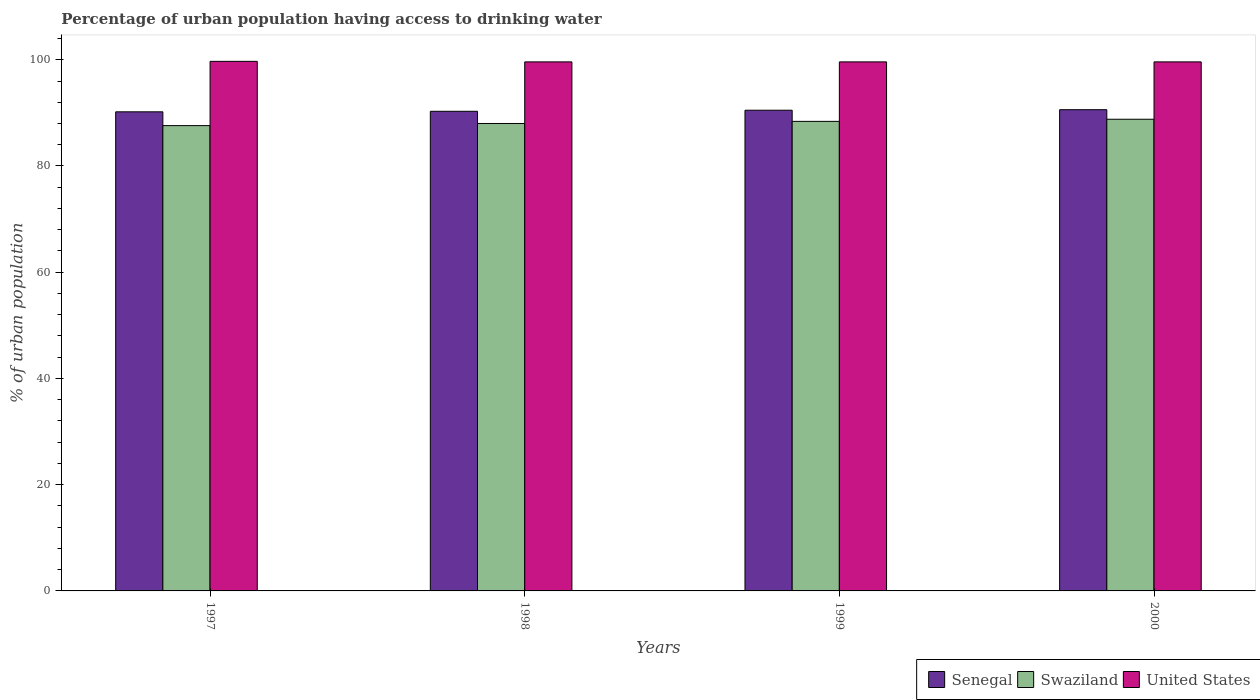How many different coloured bars are there?
Your answer should be compact. 3. Are the number of bars on each tick of the X-axis equal?
Ensure brevity in your answer.  Yes. How many bars are there on the 3rd tick from the right?
Give a very brief answer. 3. In how many cases, is the number of bars for a given year not equal to the number of legend labels?
Your response must be concise. 0. What is the percentage of urban population having access to drinking water in United States in 2000?
Give a very brief answer. 99.6. Across all years, what is the maximum percentage of urban population having access to drinking water in Senegal?
Provide a succinct answer. 90.6. Across all years, what is the minimum percentage of urban population having access to drinking water in United States?
Provide a succinct answer. 99.6. In which year was the percentage of urban population having access to drinking water in Senegal minimum?
Keep it short and to the point. 1997. What is the total percentage of urban population having access to drinking water in Senegal in the graph?
Offer a terse response. 361.6. What is the difference between the percentage of urban population having access to drinking water in Senegal in 1999 and that in 2000?
Your answer should be compact. -0.1. What is the average percentage of urban population having access to drinking water in Swaziland per year?
Ensure brevity in your answer.  88.2. In the year 1998, what is the difference between the percentage of urban population having access to drinking water in United States and percentage of urban population having access to drinking water in Senegal?
Ensure brevity in your answer.  9.3. In how many years, is the percentage of urban population having access to drinking water in Swaziland greater than 60 %?
Provide a short and direct response. 4. What is the ratio of the percentage of urban population having access to drinking water in United States in 1997 to that in 1999?
Ensure brevity in your answer.  1. Is the difference between the percentage of urban population having access to drinking water in United States in 1998 and 2000 greater than the difference between the percentage of urban population having access to drinking water in Senegal in 1998 and 2000?
Your answer should be compact. Yes. What is the difference between the highest and the second highest percentage of urban population having access to drinking water in Swaziland?
Your response must be concise. 0.4. What is the difference between the highest and the lowest percentage of urban population having access to drinking water in Swaziland?
Your answer should be very brief. 1.2. Is the sum of the percentage of urban population having access to drinking water in Senegal in 1997 and 1999 greater than the maximum percentage of urban population having access to drinking water in Swaziland across all years?
Keep it short and to the point. Yes. What does the 1st bar from the left in 1999 represents?
Your response must be concise. Senegal. Is it the case that in every year, the sum of the percentage of urban population having access to drinking water in United States and percentage of urban population having access to drinking water in Swaziland is greater than the percentage of urban population having access to drinking water in Senegal?
Give a very brief answer. Yes. Are all the bars in the graph horizontal?
Give a very brief answer. No. How many years are there in the graph?
Offer a terse response. 4. What is the difference between two consecutive major ticks on the Y-axis?
Give a very brief answer. 20. Does the graph contain any zero values?
Make the answer very short. No. What is the title of the graph?
Keep it short and to the point. Percentage of urban population having access to drinking water. What is the label or title of the Y-axis?
Offer a terse response. % of urban population. What is the % of urban population of Senegal in 1997?
Provide a short and direct response. 90.2. What is the % of urban population of Swaziland in 1997?
Ensure brevity in your answer.  87.6. What is the % of urban population of United States in 1997?
Make the answer very short. 99.7. What is the % of urban population of Senegal in 1998?
Provide a short and direct response. 90.3. What is the % of urban population in Swaziland in 1998?
Keep it short and to the point. 88. What is the % of urban population in United States in 1998?
Provide a short and direct response. 99.6. What is the % of urban population in Senegal in 1999?
Offer a very short reply. 90.5. What is the % of urban population in Swaziland in 1999?
Make the answer very short. 88.4. What is the % of urban population in United States in 1999?
Offer a terse response. 99.6. What is the % of urban population of Senegal in 2000?
Provide a succinct answer. 90.6. What is the % of urban population in Swaziland in 2000?
Provide a short and direct response. 88.8. What is the % of urban population in United States in 2000?
Give a very brief answer. 99.6. Across all years, what is the maximum % of urban population of Senegal?
Give a very brief answer. 90.6. Across all years, what is the maximum % of urban population in Swaziland?
Your response must be concise. 88.8. Across all years, what is the maximum % of urban population in United States?
Make the answer very short. 99.7. Across all years, what is the minimum % of urban population of Senegal?
Offer a very short reply. 90.2. Across all years, what is the minimum % of urban population of Swaziland?
Make the answer very short. 87.6. Across all years, what is the minimum % of urban population in United States?
Your response must be concise. 99.6. What is the total % of urban population in Senegal in the graph?
Make the answer very short. 361.6. What is the total % of urban population in Swaziland in the graph?
Keep it short and to the point. 352.8. What is the total % of urban population of United States in the graph?
Offer a terse response. 398.5. What is the difference between the % of urban population in Senegal in 1997 and that in 1998?
Your answer should be very brief. -0.1. What is the difference between the % of urban population of Swaziland in 1997 and that in 1998?
Give a very brief answer. -0.4. What is the difference between the % of urban population in Swaziland in 1997 and that in 1999?
Keep it short and to the point. -0.8. What is the difference between the % of urban population of United States in 1997 and that in 1999?
Offer a terse response. 0.1. What is the difference between the % of urban population in United States in 1998 and that in 1999?
Give a very brief answer. 0. What is the difference between the % of urban population of Senegal in 1998 and that in 2000?
Offer a very short reply. -0.3. What is the difference between the % of urban population in Swaziland in 1999 and that in 2000?
Your answer should be very brief. -0.4. What is the difference between the % of urban population in Senegal in 1997 and the % of urban population in Swaziland in 1998?
Offer a very short reply. 2.2. What is the difference between the % of urban population of Swaziland in 1997 and the % of urban population of United States in 1998?
Your answer should be very brief. -12. What is the difference between the % of urban population in Senegal in 1997 and the % of urban population in United States in 1999?
Make the answer very short. -9.4. What is the difference between the % of urban population in Swaziland in 1997 and the % of urban population in United States in 1999?
Keep it short and to the point. -12. What is the difference between the % of urban population of Senegal in 1997 and the % of urban population of Swaziland in 2000?
Offer a very short reply. 1.4. What is the difference between the % of urban population in Senegal in 1998 and the % of urban population in Swaziland in 1999?
Ensure brevity in your answer.  1.9. What is the difference between the % of urban population of Senegal in 1998 and the % of urban population of United States in 1999?
Give a very brief answer. -9.3. What is the difference between the % of urban population of Senegal in 1998 and the % of urban population of Swaziland in 2000?
Your response must be concise. 1.5. What is the difference between the % of urban population in Senegal in 1998 and the % of urban population in United States in 2000?
Your answer should be very brief. -9.3. What is the difference between the % of urban population of Senegal in 1999 and the % of urban population of Swaziland in 2000?
Provide a short and direct response. 1.7. What is the difference between the % of urban population of Swaziland in 1999 and the % of urban population of United States in 2000?
Offer a very short reply. -11.2. What is the average % of urban population of Senegal per year?
Provide a succinct answer. 90.4. What is the average % of urban population of Swaziland per year?
Offer a very short reply. 88.2. What is the average % of urban population of United States per year?
Offer a very short reply. 99.62. In the year 1997, what is the difference between the % of urban population in Senegal and % of urban population in United States?
Give a very brief answer. -9.5. In the year 1997, what is the difference between the % of urban population of Swaziland and % of urban population of United States?
Offer a terse response. -12.1. In the year 1998, what is the difference between the % of urban population of Senegal and % of urban population of Swaziland?
Make the answer very short. 2.3. In the year 1998, what is the difference between the % of urban population in Swaziland and % of urban population in United States?
Your answer should be compact. -11.6. In the year 1999, what is the difference between the % of urban population of Senegal and % of urban population of Swaziland?
Make the answer very short. 2.1. In the year 1999, what is the difference between the % of urban population in Senegal and % of urban population in United States?
Ensure brevity in your answer.  -9.1. In the year 2000, what is the difference between the % of urban population of Senegal and % of urban population of Swaziland?
Offer a very short reply. 1.8. What is the ratio of the % of urban population of Swaziland in 1997 to that in 1999?
Offer a very short reply. 0.99. What is the ratio of the % of urban population of Senegal in 1997 to that in 2000?
Offer a very short reply. 1. What is the ratio of the % of urban population of Swaziland in 1997 to that in 2000?
Offer a terse response. 0.99. What is the ratio of the % of urban population of United States in 1997 to that in 2000?
Make the answer very short. 1. What is the ratio of the % of urban population in Senegal in 1998 to that in 1999?
Keep it short and to the point. 1. What is the ratio of the % of urban population in Senegal in 1999 to that in 2000?
Offer a very short reply. 1. What is the ratio of the % of urban population of United States in 1999 to that in 2000?
Provide a succinct answer. 1. What is the difference between the highest and the second highest % of urban population in Senegal?
Your response must be concise. 0.1. What is the difference between the highest and the second highest % of urban population in Swaziland?
Provide a succinct answer. 0.4. What is the difference between the highest and the lowest % of urban population of Senegal?
Give a very brief answer. 0.4. 